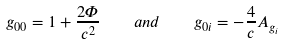Convert formula to latex. <formula><loc_0><loc_0><loc_500><loc_500>g _ { 0 0 } = 1 + \frac { 2 \Phi } { c ^ { 2 } } \quad a n d \quad g _ { 0 i } = - \frac { 4 } { c } A _ { g _ { i } }</formula> 